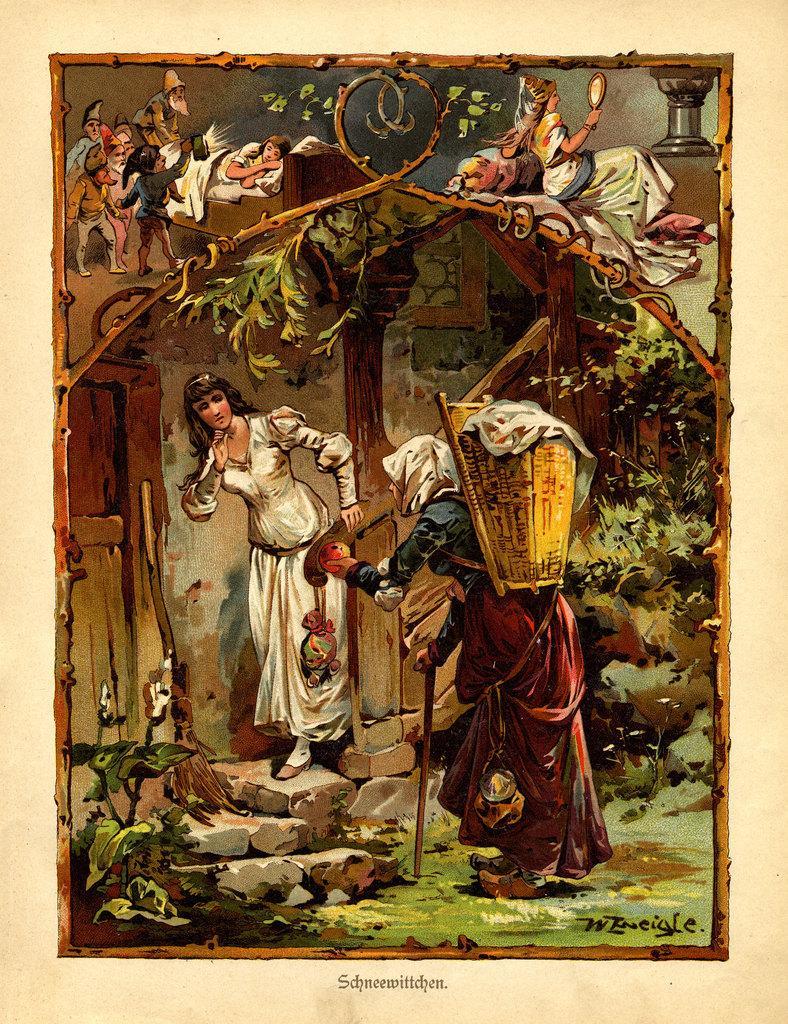Describe this image in one or two sentences. In this picture we can see poster, in this poster there are people and we can see plants, rocks and wall. At the bottom of the image we can see text. 